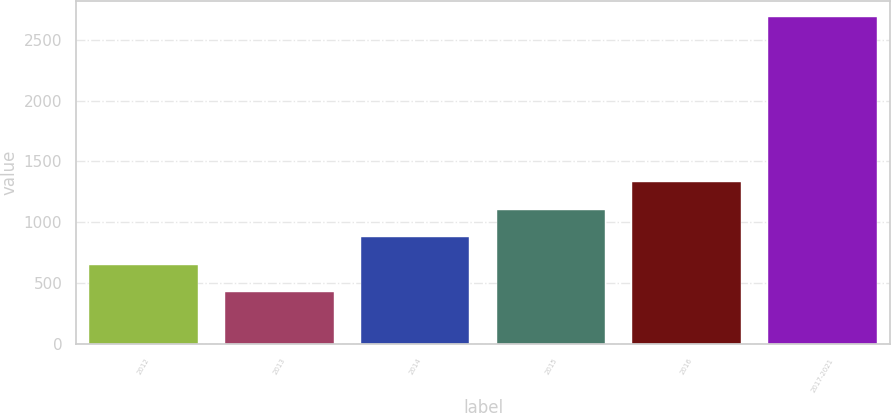Convert chart to OTSL. <chart><loc_0><loc_0><loc_500><loc_500><bar_chart><fcel>2012<fcel>2013<fcel>2014<fcel>2015<fcel>2016<fcel>2017-2021<nl><fcel>650.3<fcel>424<fcel>876.6<fcel>1102.9<fcel>1329.2<fcel>2687<nl></chart> 